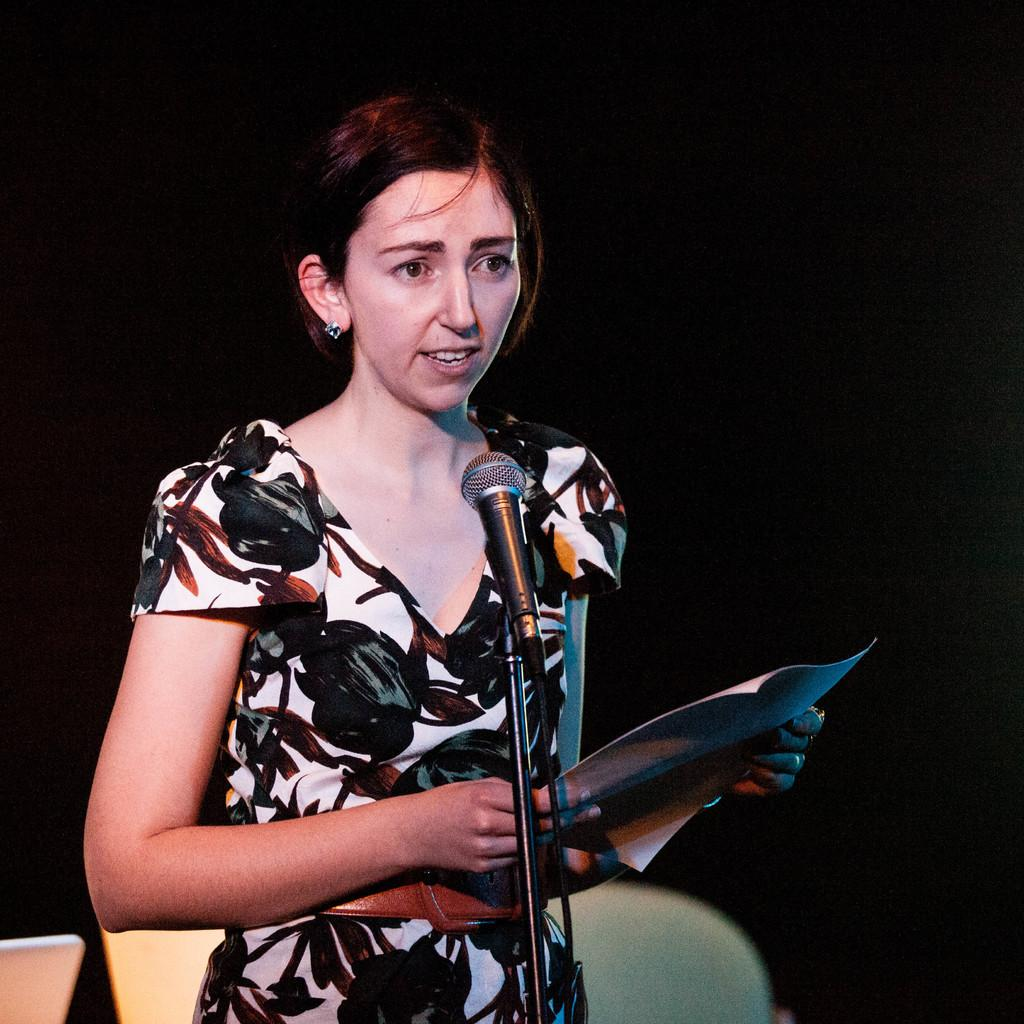Who is the main subject in the image? There is a lady in the image. What is the lady holding in the image? The lady is holding a paper. How is the lady communicating in the image? The lady is speaking through a microphone. What is the microphone attached to in the image? The microphone is attached to a stand. What type of furniture is present in the image? There are chairs in the image. What type of cat can be seen walking on the road in the image? There is no cat or road present in the image; it features a lady holding a paper and speaking through a microphone. In which country is the lady giving her speech in the image? The image does not provide any information about the country where the lady is giving her speech. 